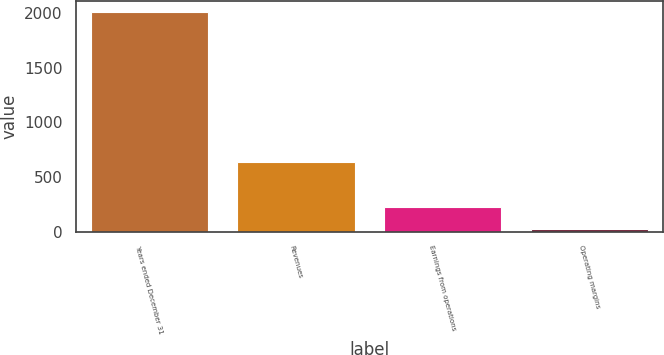<chart> <loc_0><loc_0><loc_500><loc_500><bar_chart><fcel>Years ended December 31<fcel>Revenues<fcel>Earnings from operations<fcel>Operating margins<nl><fcel>2010<fcel>639<fcel>222.6<fcel>24<nl></chart> 